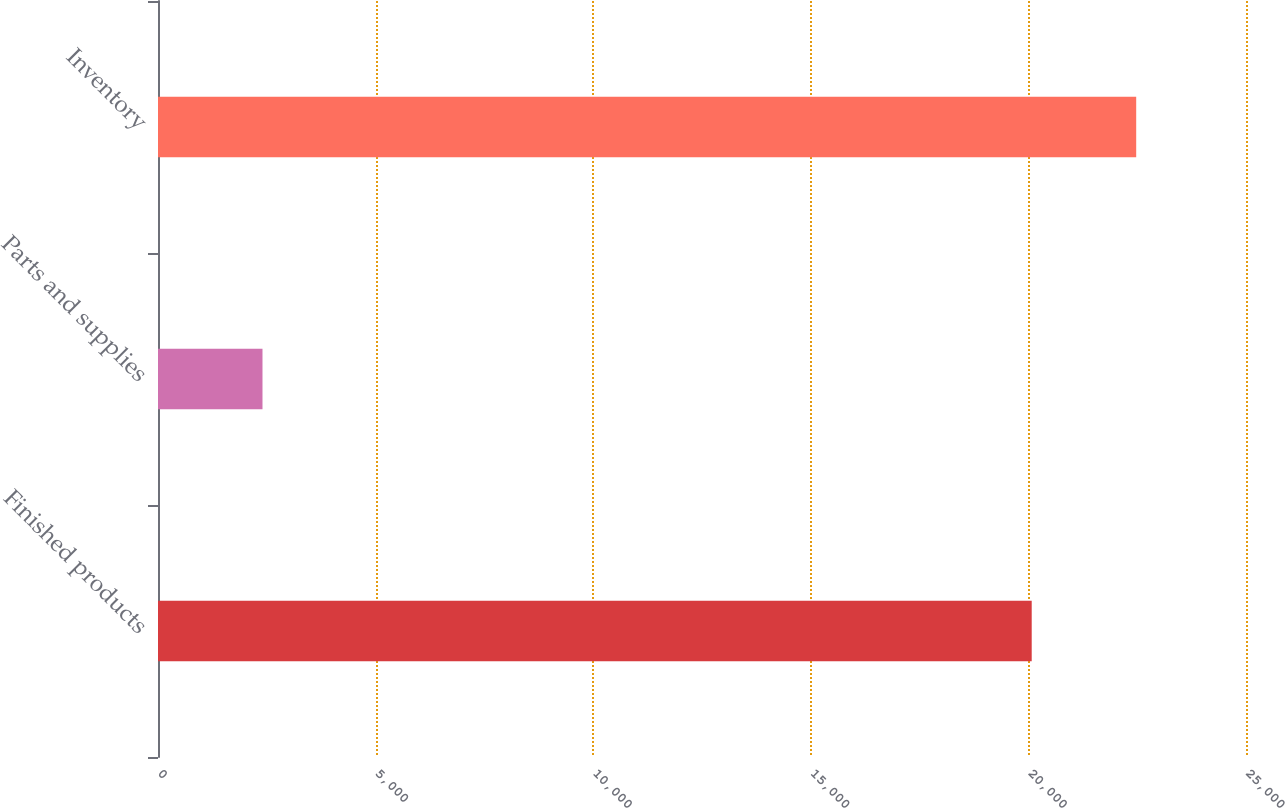Convert chart to OTSL. <chart><loc_0><loc_0><loc_500><loc_500><bar_chart><fcel>Finished products<fcel>Parts and supplies<fcel>Inventory<nl><fcel>20076<fcel>2401<fcel>22477<nl></chart> 